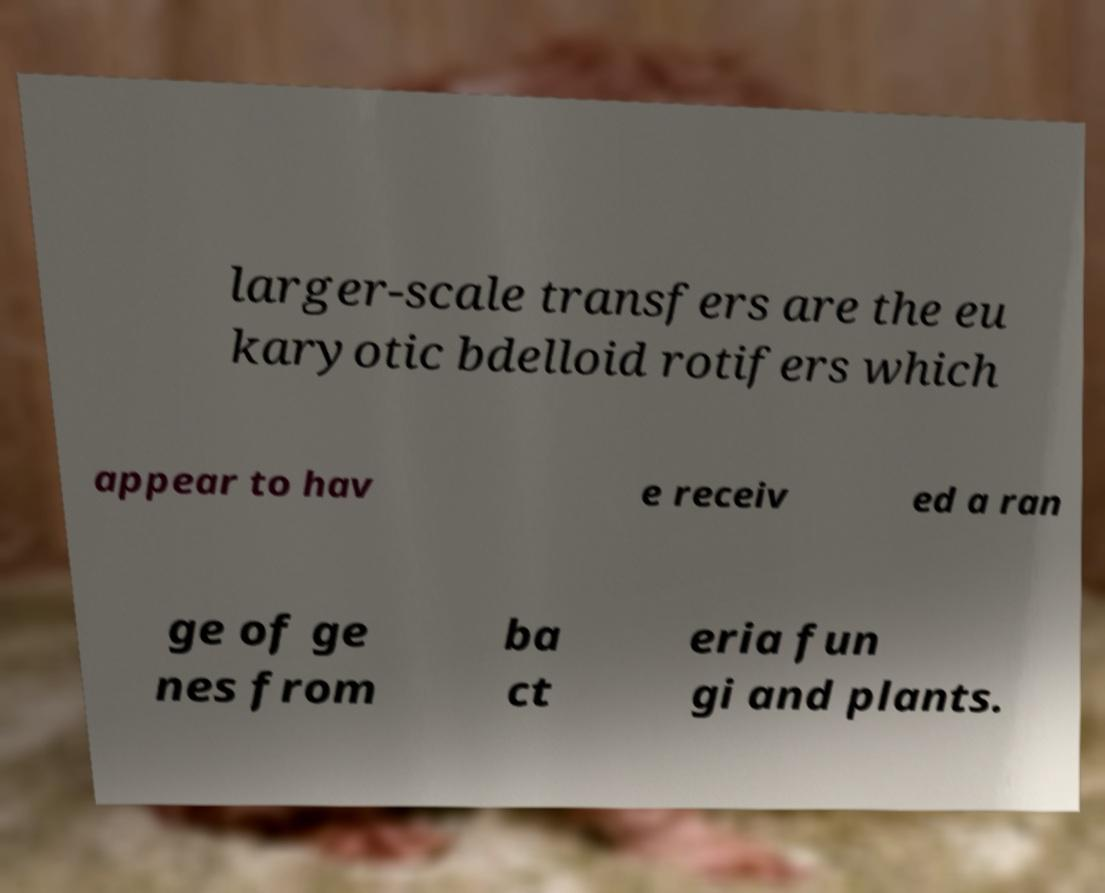Could you assist in decoding the text presented in this image and type it out clearly? larger-scale transfers are the eu karyotic bdelloid rotifers which appear to hav e receiv ed a ran ge of ge nes from ba ct eria fun gi and plants. 